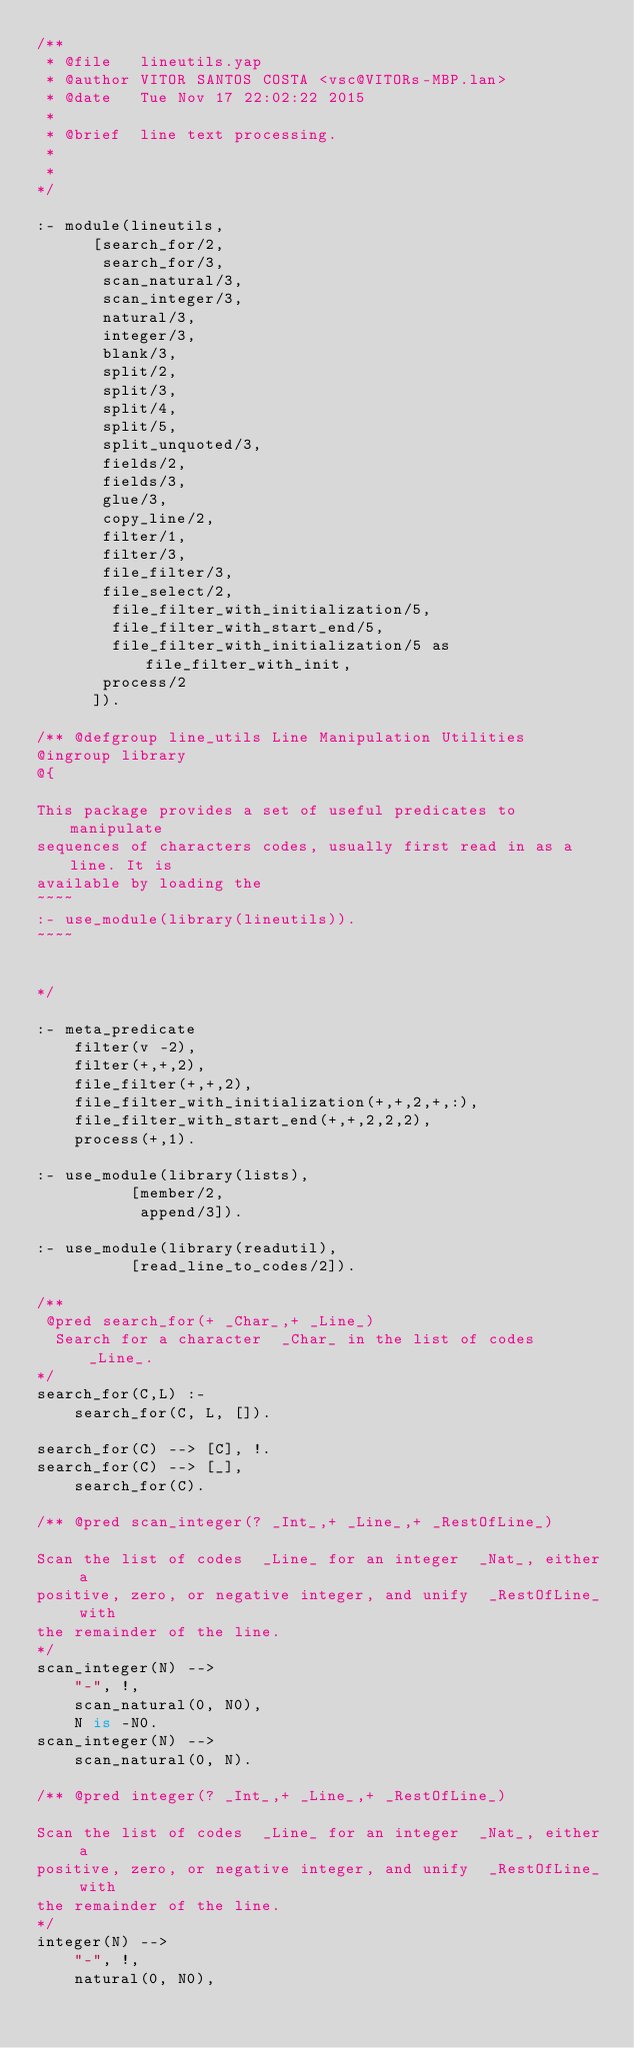Convert code to text. <code><loc_0><loc_0><loc_500><loc_500><_Prolog_>/**
 * @file   lineutils.yap
 * @author VITOR SANTOS COSTA <vsc@VITORs-MBP.lan>
 * @date   Tue Nov 17 22:02:22 2015
 * 
 * @brief  line text processing.
 * 
 * 
*/

:- module(lineutils,
	  [search_for/2,
	   search_for/3,
	   scan_natural/3,
	   scan_integer/3,
	   natural/3,
	   integer/3,
	   blank/3,
	   split/2,
	   split/3,
	   split/4,
	   split/5,
       split_unquoted/3,
	   fields/2,
	   fields/3,
	   glue/3,
	   copy_line/2,
	   filter/1,
	   filter/3,
	   file_filter/3,
       file_select/2,
		file_filter_with_initialization/5,
		file_filter_with_start_end/5,
		file_filter_with_initialization/5 as file_filter_with_init,
	   process/2
	  ]).

/** @defgroup line_utils Line Manipulation Utilities
@ingroup library
@{

This package provides a set of useful predicates to manipulate
sequences of characters codes, usually first read in as a line. It is
available by loading the
~~~~
:- use_module(library(lineutils)).
~~~~


*/

:- meta_predicate
	filter(v -2),
	filter(+,+,2),
	file_filter(+,+,2),
	file_filter_with_initialization(+,+,2,+,:),
	file_filter_with_start_end(+,+,2,2,2),
	process(+,1).

:- use_module(library(lists),
	      [member/2,
	       append/3]).

:- use_module(library(readutil),
	      [read_line_to_codes/2]).

/**
 @pred search_for(+ _Char_,+ _Line_)
  Search for a character  _Char_ in the list of codes  _Line_.
*/
search_for(C,L) :-
	search_for(C, L, []).

search_for(C) --> [C], !.
search_for(C) --> [_],
	search_for(C).

/** @pred scan_integer(? _Int_,+ _Line_,+ _RestOfLine_)

Scan the list of codes  _Line_ for an integer  _Nat_, either a
positive, zero, or negative integer, and unify  _RestOfLine_ with
the remainder of the line.
*/
scan_integer(N) -->
	"-", !,
	scan_natural(0, N0),
	N is -N0.
scan_integer(N) -->
	scan_natural(0, N).

/** @pred integer(? _Int_,+ _Line_,+ _RestOfLine_)

Scan the list of codes  _Line_ for an integer  _Nat_, either a
positive, zero, or negative integer, and unify  _RestOfLine_ with
the remainder of the line.
*/
integer(N) -->
	"-", !,
	natural(0, N0),</code> 